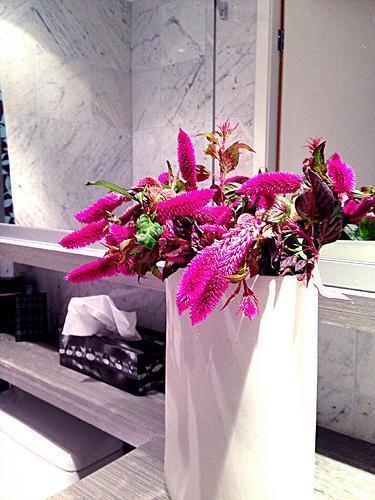How many containers are holding the flowers?
Give a very brief answer. 1. 